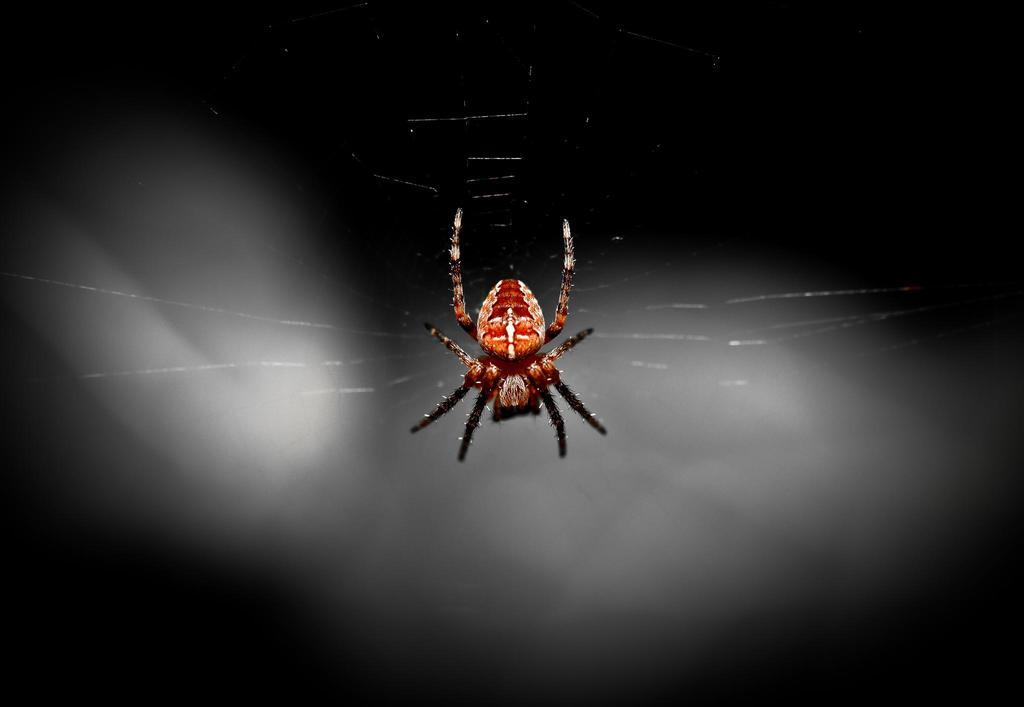What is the main subject in the center of the image? There is a spider in the center of the image. What type of sweater is the spider wearing in the image? There is no sweater present in the image, as spiders do not wear clothing. 